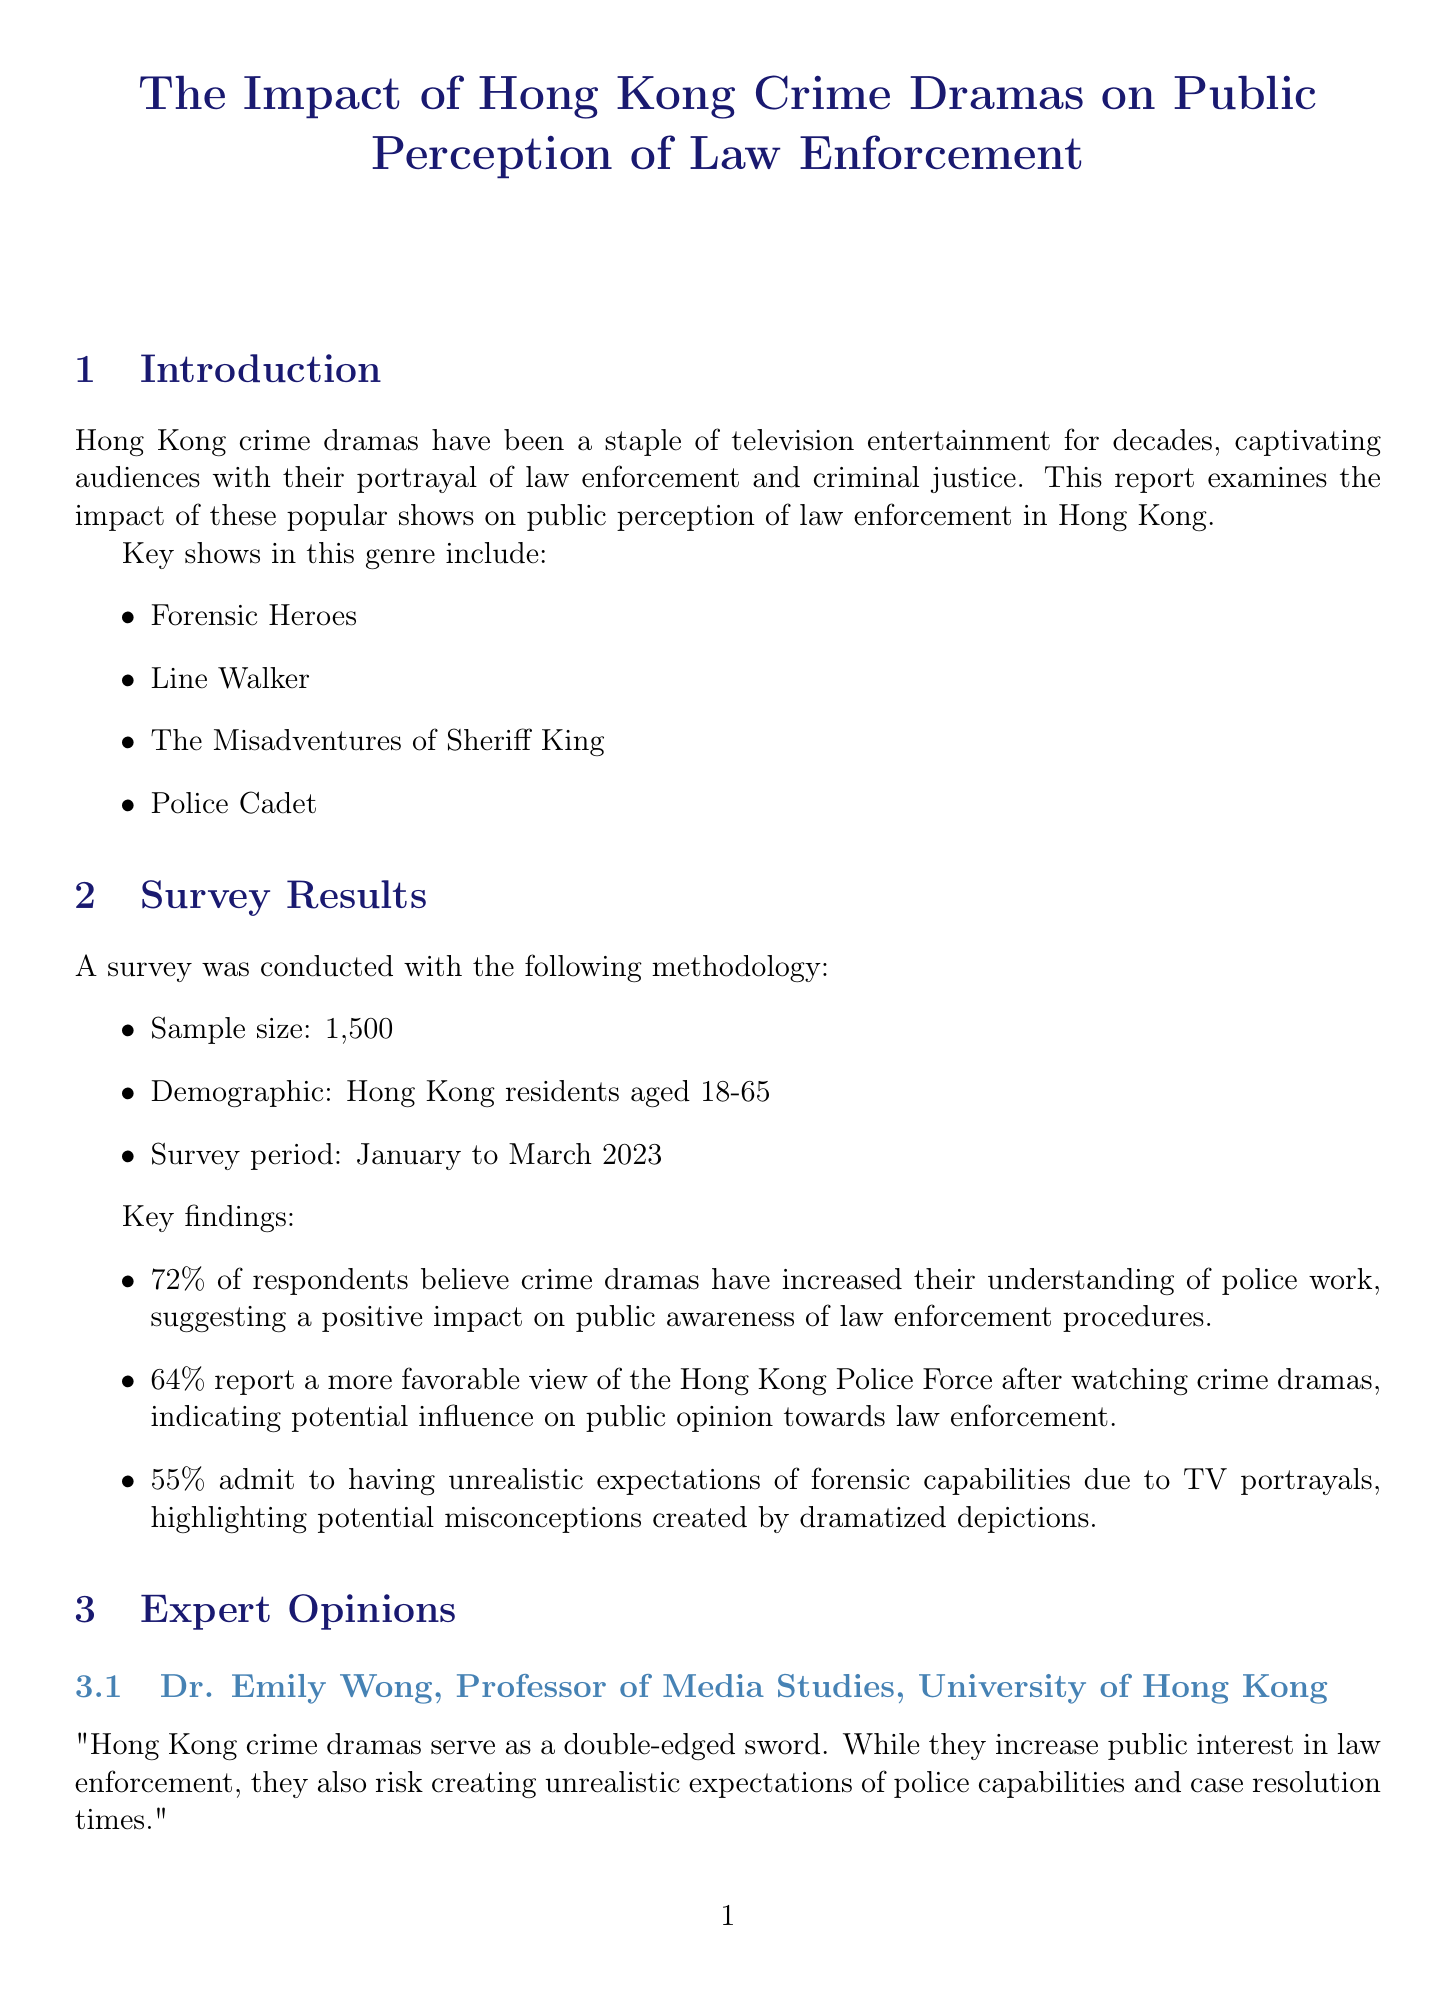what is the survey period? The survey was conducted from January to March 2023.
Answer: January to March 2023 how many respondents believed crime dramas increased their understanding of police work? According to the survey results, 72% of respondents believe crime dramas have increased their understanding of police work.
Answer: 72% who is the Professor of Media Studies at the University of Hong Kong? The document mentions Dr. Emily Wong as the Professor of Media Studies at the University of Hong Kong.
Answer: Dr. Emily Wong what impact did 'Forensic Heroes IV' have on forensic science career applications? The report states that applications to forensic science programs increased by 30% following the airing of 'Forensic Heroes IV'.
Answer: 30% what is a challenge mentioned regarding crime dramas? The report lists several challenges, including the potential glorification of violence and criminal behavior.
Answer: Glorification of violence what is the recommendation in the conclusion? The conclusion recommends continued collaboration between the entertainment industry and law enforcement for responsible portrayal.
Answer: Continued collaboration what percentage of survey respondents had unrealistic expectations of forensic capabilities? The survey found that 55% of respondents admit to having unrealistic expectations of forensic capabilities due to TV portrayals.
Answer: 55% which show raised awareness about undercover police operations? The report indicates that 'Line Walker: Bull Fight' raised awareness about undercover police operations.
Answer: Line Walker: Bull Fight 